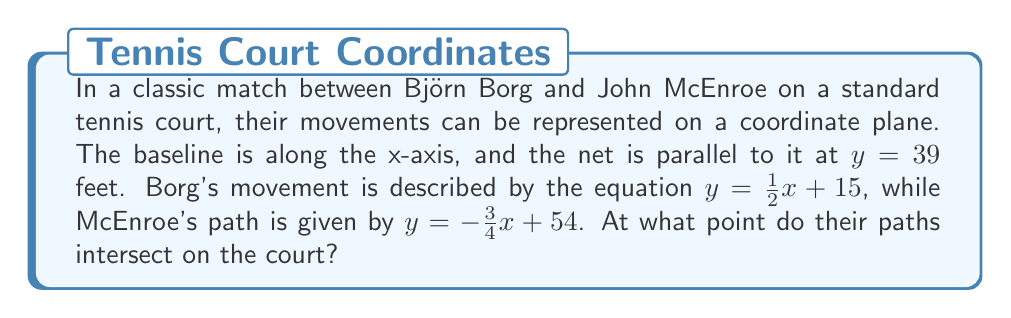Provide a solution to this math problem. To find the intersection point of Borg's and McEnroe's paths, we need to solve the system of equations:

$$\begin{cases}
y = \frac{1}{2}x + 15 & \text{(Borg's path)} \\
y = -\frac{3}{4}x + 54 & \text{(McEnroe's path)}
\end{cases}$$

Step 1: Set the equations equal to each other:
$\frac{1}{2}x + 15 = -\frac{3}{4}x + 54$

Step 2: Add $\frac{3}{4}x$ to both sides:
$\frac{5}{4}x + 15 = 54$

Step 3: Subtract 15 from both sides:
$\frac{5}{4}x = 39$

Step 4: Multiply both sides by $\frac{4}{5}$:
$x = 39 \cdot \frac{4}{5} = 31.2$

Step 5: Substitute this x-value into either equation to find y. Let's use Borg's equation:
$y = \frac{1}{2}(31.2) + 15 = 15.6 + 15 = 30.6$

Therefore, the intersection point is (31.2, 30.6).

Step 6: Verify that this point is within the court boundaries:
- The x-coordinate (31.2) is less than 39, so it's before the net.
- The y-coordinate (30.6) is less than 39, so it's within the court's length.

[asy]
import geometry;

size(200);
draw((0,0)--(78,0), arrow=Arrow(TeXHead));
draw((0,0)--(0,78), arrow=Arrow(TeXHead));
draw((0,39)--(78,39), dashed);
draw((0,15)--(62.4,46.2), blue);
draw((72,0)--(0,54), red);
dot((31.2,30.6));
label("(31.2, 30.6)", (31.2,30.6), NE);
label("Net", (39,41), E);
label("Baseline", (0,-2), W);
label("Borg", (62,46), NE, blue);
label("McEnroe", (2,54), NW, red);
[/asy]
Answer: (31.2, 30.6) 